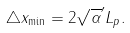<formula> <loc_0><loc_0><loc_500><loc_500>\triangle x _ { \min } = 2 \sqrt { \alpha } ^ { \prime } L _ { p } .</formula> 